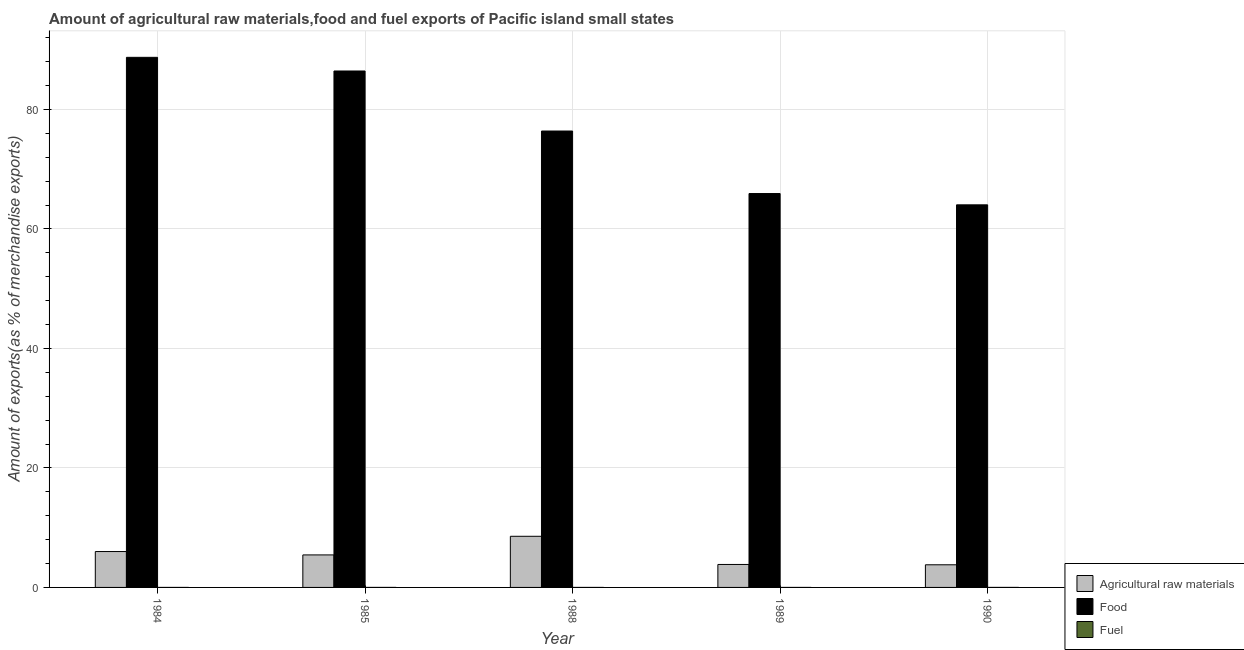How many groups of bars are there?
Offer a very short reply. 5. How many bars are there on the 1st tick from the left?
Provide a short and direct response. 3. What is the percentage of raw materials exports in 1990?
Make the answer very short. 3.79. Across all years, what is the maximum percentage of fuel exports?
Provide a succinct answer. 0. Across all years, what is the minimum percentage of raw materials exports?
Give a very brief answer. 3.79. In which year was the percentage of raw materials exports minimum?
Your response must be concise. 1990. What is the total percentage of raw materials exports in the graph?
Give a very brief answer. 27.64. What is the difference between the percentage of raw materials exports in 1984 and that in 1990?
Provide a succinct answer. 2.22. What is the difference between the percentage of fuel exports in 1988 and the percentage of raw materials exports in 1990?
Offer a terse response. -0. What is the average percentage of fuel exports per year?
Your answer should be very brief. 0. In how many years, is the percentage of raw materials exports greater than 20 %?
Keep it short and to the point. 0. What is the ratio of the percentage of fuel exports in 1985 to that in 1989?
Ensure brevity in your answer.  32.68. Is the difference between the percentage of fuel exports in 1988 and 1989 greater than the difference between the percentage of raw materials exports in 1988 and 1989?
Provide a short and direct response. No. What is the difference between the highest and the second highest percentage of food exports?
Make the answer very short. 2.29. What is the difference between the highest and the lowest percentage of fuel exports?
Your answer should be compact. 0. What does the 2nd bar from the left in 1988 represents?
Ensure brevity in your answer.  Food. What does the 3rd bar from the right in 1990 represents?
Give a very brief answer. Agricultural raw materials. Is it the case that in every year, the sum of the percentage of raw materials exports and percentage of food exports is greater than the percentage of fuel exports?
Offer a terse response. Yes. How many bars are there?
Provide a short and direct response. 15. How many legend labels are there?
Your response must be concise. 3. How are the legend labels stacked?
Your answer should be very brief. Vertical. What is the title of the graph?
Give a very brief answer. Amount of agricultural raw materials,food and fuel exports of Pacific island small states. Does "Liquid fuel" appear as one of the legend labels in the graph?
Your answer should be very brief. No. What is the label or title of the X-axis?
Offer a terse response. Year. What is the label or title of the Y-axis?
Keep it short and to the point. Amount of exports(as % of merchandise exports). What is the Amount of exports(as % of merchandise exports) in Agricultural raw materials in 1984?
Provide a succinct answer. 6.01. What is the Amount of exports(as % of merchandise exports) of Food in 1984?
Your answer should be compact. 88.73. What is the Amount of exports(as % of merchandise exports) of Fuel in 1984?
Ensure brevity in your answer.  9.24055640270179e-5. What is the Amount of exports(as % of merchandise exports) of Agricultural raw materials in 1985?
Provide a short and direct response. 5.44. What is the Amount of exports(as % of merchandise exports) in Food in 1985?
Provide a succinct answer. 86.45. What is the Amount of exports(as % of merchandise exports) in Fuel in 1985?
Your answer should be compact. 0. What is the Amount of exports(as % of merchandise exports) of Agricultural raw materials in 1988?
Your answer should be very brief. 8.56. What is the Amount of exports(as % of merchandise exports) in Food in 1988?
Your response must be concise. 76.4. What is the Amount of exports(as % of merchandise exports) of Fuel in 1988?
Keep it short and to the point. 0. What is the Amount of exports(as % of merchandise exports) in Agricultural raw materials in 1989?
Offer a terse response. 3.84. What is the Amount of exports(as % of merchandise exports) of Food in 1989?
Your answer should be very brief. 65.93. What is the Amount of exports(as % of merchandise exports) in Fuel in 1989?
Your response must be concise. 3.98845700657726e-5. What is the Amount of exports(as % of merchandise exports) of Agricultural raw materials in 1990?
Provide a succinct answer. 3.79. What is the Amount of exports(as % of merchandise exports) of Food in 1990?
Provide a succinct answer. 64.04. What is the Amount of exports(as % of merchandise exports) of Fuel in 1990?
Offer a very short reply. 0. Across all years, what is the maximum Amount of exports(as % of merchandise exports) in Agricultural raw materials?
Ensure brevity in your answer.  8.56. Across all years, what is the maximum Amount of exports(as % of merchandise exports) of Food?
Keep it short and to the point. 88.73. Across all years, what is the maximum Amount of exports(as % of merchandise exports) in Fuel?
Provide a short and direct response. 0. Across all years, what is the minimum Amount of exports(as % of merchandise exports) of Agricultural raw materials?
Your response must be concise. 3.79. Across all years, what is the minimum Amount of exports(as % of merchandise exports) of Food?
Your answer should be very brief. 64.04. Across all years, what is the minimum Amount of exports(as % of merchandise exports) in Fuel?
Your answer should be compact. 3.98845700657726e-5. What is the total Amount of exports(as % of merchandise exports) in Agricultural raw materials in the graph?
Your answer should be compact. 27.64. What is the total Amount of exports(as % of merchandise exports) in Food in the graph?
Make the answer very short. 381.55. What is the total Amount of exports(as % of merchandise exports) in Fuel in the graph?
Offer a terse response. 0. What is the difference between the Amount of exports(as % of merchandise exports) in Agricultural raw materials in 1984 and that in 1985?
Your answer should be very brief. 0.57. What is the difference between the Amount of exports(as % of merchandise exports) in Food in 1984 and that in 1985?
Give a very brief answer. 2.29. What is the difference between the Amount of exports(as % of merchandise exports) in Fuel in 1984 and that in 1985?
Keep it short and to the point. -0. What is the difference between the Amount of exports(as % of merchandise exports) of Agricultural raw materials in 1984 and that in 1988?
Provide a short and direct response. -2.55. What is the difference between the Amount of exports(as % of merchandise exports) of Food in 1984 and that in 1988?
Give a very brief answer. 12.33. What is the difference between the Amount of exports(as % of merchandise exports) in Fuel in 1984 and that in 1988?
Your answer should be very brief. -0. What is the difference between the Amount of exports(as % of merchandise exports) of Agricultural raw materials in 1984 and that in 1989?
Your answer should be very brief. 2.16. What is the difference between the Amount of exports(as % of merchandise exports) of Food in 1984 and that in 1989?
Your answer should be very brief. 22.8. What is the difference between the Amount of exports(as % of merchandise exports) in Agricultural raw materials in 1984 and that in 1990?
Make the answer very short. 2.22. What is the difference between the Amount of exports(as % of merchandise exports) of Food in 1984 and that in 1990?
Offer a terse response. 24.69. What is the difference between the Amount of exports(as % of merchandise exports) in Fuel in 1984 and that in 1990?
Your answer should be compact. -0. What is the difference between the Amount of exports(as % of merchandise exports) of Agricultural raw materials in 1985 and that in 1988?
Your answer should be very brief. -3.12. What is the difference between the Amount of exports(as % of merchandise exports) in Food in 1985 and that in 1988?
Give a very brief answer. 10.05. What is the difference between the Amount of exports(as % of merchandise exports) in Fuel in 1985 and that in 1988?
Your answer should be compact. 0. What is the difference between the Amount of exports(as % of merchandise exports) of Agricultural raw materials in 1985 and that in 1989?
Give a very brief answer. 1.6. What is the difference between the Amount of exports(as % of merchandise exports) in Food in 1985 and that in 1989?
Provide a short and direct response. 20.51. What is the difference between the Amount of exports(as % of merchandise exports) of Fuel in 1985 and that in 1989?
Your answer should be very brief. 0. What is the difference between the Amount of exports(as % of merchandise exports) in Agricultural raw materials in 1985 and that in 1990?
Provide a short and direct response. 1.65. What is the difference between the Amount of exports(as % of merchandise exports) of Food in 1985 and that in 1990?
Offer a terse response. 22.4. What is the difference between the Amount of exports(as % of merchandise exports) in Fuel in 1985 and that in 1990?
Provide a succinct answer. -0. What is the difference between the Amount of exports(as % of merchandise exports) in Agricultural raw materials in 1988 and that in 1989?
Offer a very short reply. 4.72. What is the difference between the Amount of exports(as % of merchandise exports) in Food in 1988 and that in 1989?
Your response must be concise. 10.46. What is the difference between the Amount of exports(as % of merchandise exports) in Fuel in 1988 and that in 1989?
Your answer should be compact. 0. What is the difference between the Amount of exports(as % of merchandise exports) in Agricultural raw materials in 1988 and that in 1990?
Offer a very short reply. 4.77. What is the difference between the Amount of exports(as % of merchandise exports) in Food in 1988 and that in 1990?
Your answer should be very brief. 12.36. What is the difference between the Amount of exports(as % of merchandise exports) of Fuel in 1988 and that in 1990?
Keep it short and to the point. -0. What is the difference between the Amount of exports(as % of merchandise exports) of Agricultural raw materials in 1989 and that in 1990?
Your response must be concise. 0.06. What is the difference between the Amount of exports(as % of merchandise exports) of Food in 1989 and that in 1990?
Provide a short and direct response. 1.89. What is the difference between the Amount of exports(as % of merchandise exports) of Fuel in 1989 and that in 1990?
Give a very brief answer. -0. What is the difference between the Amount of exports(as % of merchandise exports) in Agricultural raw materials in 1984 and the Amount of exports(as % of merchandise exports) in Food in 1985?
Your answer should be compact. -80.44. What is the difference between the Amount of exports(as % of merchandise exports) of Agricultural raw materials in 1984 and the Amount of exports(as % of merchandise exports) of Fuel in 1985?
Make the answer very short. 6.01. What is the difference between the Amount of exports(as % of merchandise exports) in Food in 1984 and the Amount of exports(as % of merchandise exports) in Fuel in 1985?
Provide a short and direct response. 88.73. What is the difference between the Amount of exports(as % of merchandise exports) in Agricultural raw materials in 1984 and the Amount of exports(as % of merchandise exports) in Food in 1988?
Keep it short and to the point. -70.39. What is the difference between the Amount of exports(as % of merchandise exports) in Agricultural raw materials in 1984 and the Amount of exports(as % of merchandise exports) in Fuel in 1988?
Keep it short and to the point. 6.01. What is the difference between the Amount of exports(as % of merchandise exports) in Food in 1984 and the Amount of exports(as % of merchandise exports) in Fuel in 1988?
Your answer should be compact. 88.73. What is the difference between the Amount of exports(as % of merchandise exports) of Agricultural raw materials in 1984 and the Amount of exports(as % of merchandise exports) of Food in 1989?
Offer a terse response. -59.93. What is the difference between the Amount of exports(as % of merchandise exports) in Agricultural raw materials in 1984 and the Amount of exports(as % of merchandise exports) in Fuel in 1989?
Your response must be concise. 6.01. What is the difference between the Amount of exports(as % of merchandise exports) of Food in 1984 and the Amount of exports(as % of merchandise exports) of Fuel in 1989?
Make the answer very short. 88.73. What is the difference between the Amount of exports(as % of merchandise exports) of Agricultural raw materials in 1984 and the Amount of exports(as % of merchandise exports) of Food in 1990?
Ensure brevity in your answer.  -58.03. What is the difference between the Amount of exports(as % of merchandise exports) of Agricultural raw materials in 1984 and the Amount of exports(as % of merchandise exports) of Fuel in 1990?
Provide a short and direct response. 6.01. What is the difference between the Amount of exports(as % of merchandise exports) of Food in 1984 and the Amount of exports(as % of merchandise exports) of Fuel in 1990?
Offer a very short reply. 88.73. What is the difference between the Amount of exports(as % of merchandise exports) of Agricultural raw materials in 1985 and the Amount of exports(as % of merchandise exports) of Food in 1988?
Offer a terse response. -70.96. What is the difference between the Amount of exports(as % of merchandise exports) of Agricultural raw materials in 1985 and the Amount of exports(as % of merchandise exports) of Fuel in 1988?
Your response must be concise. 5.44. What is the difference between the Amount of exports(as % of merchandise exports) in Food in 1985 and the Amount of exports(as % of merchandise exports) in Fuel in 1988?
Offer a very short reply. 86.44. What is the difference between the Amount of exports(as % of merchandise exports) in Agricultural raw materials in 1985 and the Amount of exports(as % of merchandise exports) in Food in 1989?
Ensure brevity in your answer.  -60.49. What is the difference between the Amount of exports(as % of merchandise exports) in Agricultural raw materials in 1985 and the Amount of exports(as % of merchandise exports) in Fuel in 1989?
Make the answer very short. 5.44. What is the difference between the Amount of exports(as % of merchandise exports) in Food in 1985 and the Amount of exports(as % of merchandise exports) in Fuel in 1989?
Your response must be concise. 86.44. What is the difference between the Amount of exports(as % of merchandise exports) in Agricultural raw materials in 1985 and the Amount of exports(as % of merchandise exports) in Food in 1990?
Ensure brevity in your answer.  -58.6. What is the difference between the Amount of exports(as % of merchandise exports) in Agricultural raw materials in 1985 and the Amount of exports(as % of merchandise exports) in Fuel in 1990?
Ensure brevity in your answer.  5.44. What is the difference between the Amount of exports(as % of merchandise exports) of Food in 1985 and the Amount of exports(as % of merchandise exports) of Fuel in 1990?
Provide a succinct answer. 86.44. What is the difference between the Amount of exports(as % of merchandise exports) in Agricultural raw materials in 1988 and the Amount of exports(as % of merchandise exports) in Food in 1989?
Make the answer very short. -57.37. What is the difference between the Amount of exports(as % of merchandise exports) of Agricultural raw materials in 1988 and the Amount of exports(as % of merchandise exports) of Fuel in 1989?
Your answer should be very brief. 8.56. What is the difference between the Amount of exports(as % of merchandise exports) of Food in 1988 and the Amount of exports(as % of merchandise exports) of Fuel in 1989?
Keep it short and to the point. 76.4. What is the difference between the Amount of exports(as % of merchandise exports) of Agricultural raw materials in 1988 and the Amount of exports(as % of merchandise exports) of Food in 1990?
Keep it short and to the point. -55.48. What is the difference between the Amount of exports(as % of merchandise exports) in Agricultural raw materials in 1988 and the Amount of exports(as % of merchandise exports) in Fuel in 1990?
Provide a short and direct response. 8.56. What is the difference between the Amount of exports(as % of merchandise exports) of Food in 1988 and the Amount of exports(as % of merchandise exports) of Fuel in 1990?
Provide a succinct answer. 76.4. What is the difference between the Amount of exports(as % of merchandise exports) in Agricultural raw materials in 1989 and the Amount of exports(as % of merchandise exports) in Food in 1990?
Provide a succinct answer. -60.2. What is the difference between the Amount of exports(as % of merchandise exports) of Agricultural raw materials in 1989 and the Amount of exports(as % of merchandise exports) of Fuel in 1990?
Your response must be concise. 3.84. What is the difference between the Amount of exports(as % of merchandise exports) in Food in 1989 and the Amount of exports(as % of merchandise exports) in Fuel in 1990?
Your answer should be very brief. 65.93. What is the average Amount of exports(as % of merchandise exports) of Agricultural raw materials per year?
Your response must be concise. 5.53. What is the average Amount of exports(as % of merchandise exports) of Food per year?
Ensure brevity in your answer.  76.31. What is the average Amount of exports(as % of merchandise exports) in Fuel per year?
Make the answer very short. 0. In the year 1984, what is the difference between the Amount of exports(as % of merchandise exports) of Agricultural raw materials and Amount of exports(as % of merchandise exports) of Food?
Keep it short and to the point. -82.72. In the year 1984, what is the difference between the Amount of exports(as % of merchandise exports) of Agricultural raw materials and Amount of exports(as % of merchandise exports) of Fuel?
Provide a short and direct response. 6.01. In the year 1984, what is the difference between the Amount of exports(as % of merchandise exports) in Food and Amount of exports(as % of merchandise exports) in Fuel?
Keep it short and to the point. 88.73. In the year 1985, what is the difference between the Amount of exports(as % of merchandise exports) of Agricultural raw materials and Amount of exports(as % of merchandise exports) of Food?
Provide a short and direct response. -81. In the year 1985, what is the difference between the Amount of exports(as % of merchandise exports) in Agricultural raw materials and Amount of exports(as % of merchandise exports) in Fuel?
Provide a succinct answer. 5.44. In the year 1985, what is the difference between the Amount of exports(as % of merchandise exports) of Food and Amount of exports(as % of merchandise exports) of Fuel?
Provide a succinct answer. 86.44. In the year 1988, what is the difference between the Amount of exports(as % of merchandise exports) in Agricultural raw materials and Amount of exports(as % of merchandise exports) in Food?
Keep it short and to the point. -67.84. In the year 1988, what is the difference between the Amount of exports(as % of merchandise exports) in Agricultural raw materials and Amount of exports(as % of merchandise exports) in Fuel?
Provide a short and direct response. 8.56. In the year 1988, what is the difference between the Amount of exports(as % of merchandise exports) in Food and Amount of exports(as % of merchandise exports) in Fuel?
Your answer should be very brief. 76.4. In the year 1989, what is the difference between the Amount of exports(as % of merchandise exports) in Agricultural raw materials and Amount of exports(as % of merchandise exports) in Food?
Offer a very short reply. -62.09. In the year 1989, what is the difference between the Amount of exports(as % of merchandise exports) in Agricultural raw materials and Amount of exports(as % of merchandise exports) in Fuel?
Offer a terse response. 3.84. In the year 1989, what is the difference between the Amount of exports(as % of merchandise exports) of Food and Amount of exports(as % of merchandise exports) of Fuel?
Give a very brief answer. 65.93. In the year 1990, what is the difference between the Amount of exports(as % of merchandise exports) of Agricultural raw materials and Amount of exports(as % of merchandise exports) of Food?
Ensure brevity in your answer.  -60.25. In the year 1990, what is the difference between the Amount of exports(as % of merchandise exports) in Agricultural raw materials and Amount of exports(as % of merchandise exports) in Fuel?
Provide a succinct answer. 3.79. In the year 1990, what is the difference between the Amount of exports(as % of merchandise exports) of Food and Amount of exports(as % of merchandise exports) of Fuel?
Make the answer very short. 64.04. What is the ratio of the Amount of exports(as % of merchandise exports) of Agricultural raw materials in 1984 to that in 1985?
Offer a terse response. 1.1. What is the ratio of the Amount of exports(as % of merchandise exports) in Food in 1984 to that in 1985?
Keep it short and to the point. 1.03. What is the ratio of the Amount of exports(as % of merchandise exports) in Fuel in 1984 to that in 1985?
Provide a succinct answer. 0.07. What is the ratio of the Amount of exports(as % of merchandise exports) in Agricultural raw materials in 1984 to that in 1988?
Give a very brief answer. 0.7. What is the ratio of the Amount of exports(as % of merchandise exports) of Food in 1984 to that in 1988?
Your response must be concise. 1.16. What is the ratio of the Amount of exports(as % of merchandise exports) of Fuel in 1984 to that in 1988?
Give a very brief answer. 0.26. What is the ratio of the Amount of exports(as % of merchandise exports) of Agricultural raw materials in 1984 to that in 1989?
Offer a very short reply. 1.56. What is the ratio of the Amount of exports(as % of merchandise exports) of Food in 1984 to that in 1989?
Make the answer very short. 1.35. What is the ratio of the Amount of exports(as % of merchandise exports) in Fuel in 1984 to that in 1989?
Keep it short and to the point. 2.32. What is the ratio of the Amount of exports(as % of merchandise exports) of Agricultural raw materials in 1984 to that in 1990?
Ensure brevity in your answer.  1.59. What is the ratio of the Amount of exports(as % of merchandise exports) of Food in 1984 to that in 1990?
Offer a terse response. 1.39. What is the ratio of the Amount of exports(as % of merchandise exports) of Fuel in 1984 to that in 1990?
Your answer should be compact. 0.04. What is the ratio of the Amount of exports(as % of merchandise exports) in Agricultural raw materials in 1985 to that in 1988?
Ensure brevity in your answer.  0.64. What is the ratio of the Amount of exports(as % of merchandise exports) of Food in 1985 to that in 1988?
Provide a short and direct response. 1.13. What is the ratio of the Amount of exports(as % of merchandise exports) in Fuel in 1985 to that in 1988?
Keep it short and to the point. 3.64. What is the ratio of the Amount of exports(as % of merchandise exports) of Agricultural raw materials in 1985 to that in 1989?
Offer a terse response. 1.42. What is the ratio of the Amount of exports(as % of merchandise exports) in Food in 1985 to that in 1989?
Give a very brief answer. 1.31. What is the ratio of the Amount of exports(as % of merchandise exports) of Fuel in 1985 to that in 1989?
Provide a short and direct response. 32.68. What is the ratio of the Amount of exports(as % of merchandise exports) in Agricultural raw materials in 1985 to that in 1990?
Your response must be concise. 1.44. What is the ratio of the Amount of exports(as % of merchandise exports) of Food in 1985 to that in 1990?
Ensure brevity in your answer.  1.35. What is the ratio of the Amount of exports(as % of merchandise exports) of Fuel in 1985 to that in 1990?
Keep it short and to the point. 0.62. What is the ratio of the Amount of exports(as % of merchandise exports) of Agricultural raw materials in 1988 to that in 1989?
Offer a very short reply. 2.23. What is the ratio of the Amount of exports(as % of merchandise exports) of Food in 1988 to that in 1989?
Give a very brief answer. 1.16. What is the ratio of the Amount of exports(as % of merchandise exports) in Fuel in 1988 to that in 1989?
Provide a succinct answer. 8.99. What is the ratio of the Amount of exports(as % of merchandise exports) of Agricultural raw materials in 1988 to that in 1990?
Offer a terse response. 2.26. What is the ratio of the Amount of exports(as % of merchandise exports) of Food in 1988 to that in 1990?
Provide a short and direct response. 1.19. What is the ratio of the Amount of exports(as % of merchandise exports) in Fuel in 1988 to that in 1990?
Make the answer very short. 0.17. What is the ratio of the Amount of exports(as % of merchandise exports) in Agricultural raw materials in 1989 to that in 1990?
Keep it short and to the point. 1.01. What is the ratio of the Amount of exports(as % of merchandise exports) of Food in 1989 to that in 1990?
Your answer should be very brief. 1.03. What is the ratio of the Amount of exports(as % of merchandise exports) in Fuel in 1989 to that in 1990?
Make the answer very short. 0.02. What is the difference between the highest and the second highest Amount of exports(as % of merchandise exports) in Agricultural raw materials?
Provide a short and direct response. 2.55. What is the difference between the highest and the second highest Amount of exports(as % of merchandise exports) of Food?
Your answer should be compact. 2.29. What is the difference between the highest and the second highest Amount of exports(as % of merchandise exports) in Fuel?
Keep it short and to the point. 0. What is the difference between the highest and the lowest Amount of exports(as % of merchandise exports) of Agricultural raw materials?
Provide a short and direct response. 4.77. What is the difference between the highest and the lowest Amount of exports(as % of merchandise exports) in Food?
Ensure brevity in your answer.  24.69. What is the difference between the highest and the lowest Amount of exports(as % of merchandise exports) in Fuel?
Your answer should be very brief. 0. 